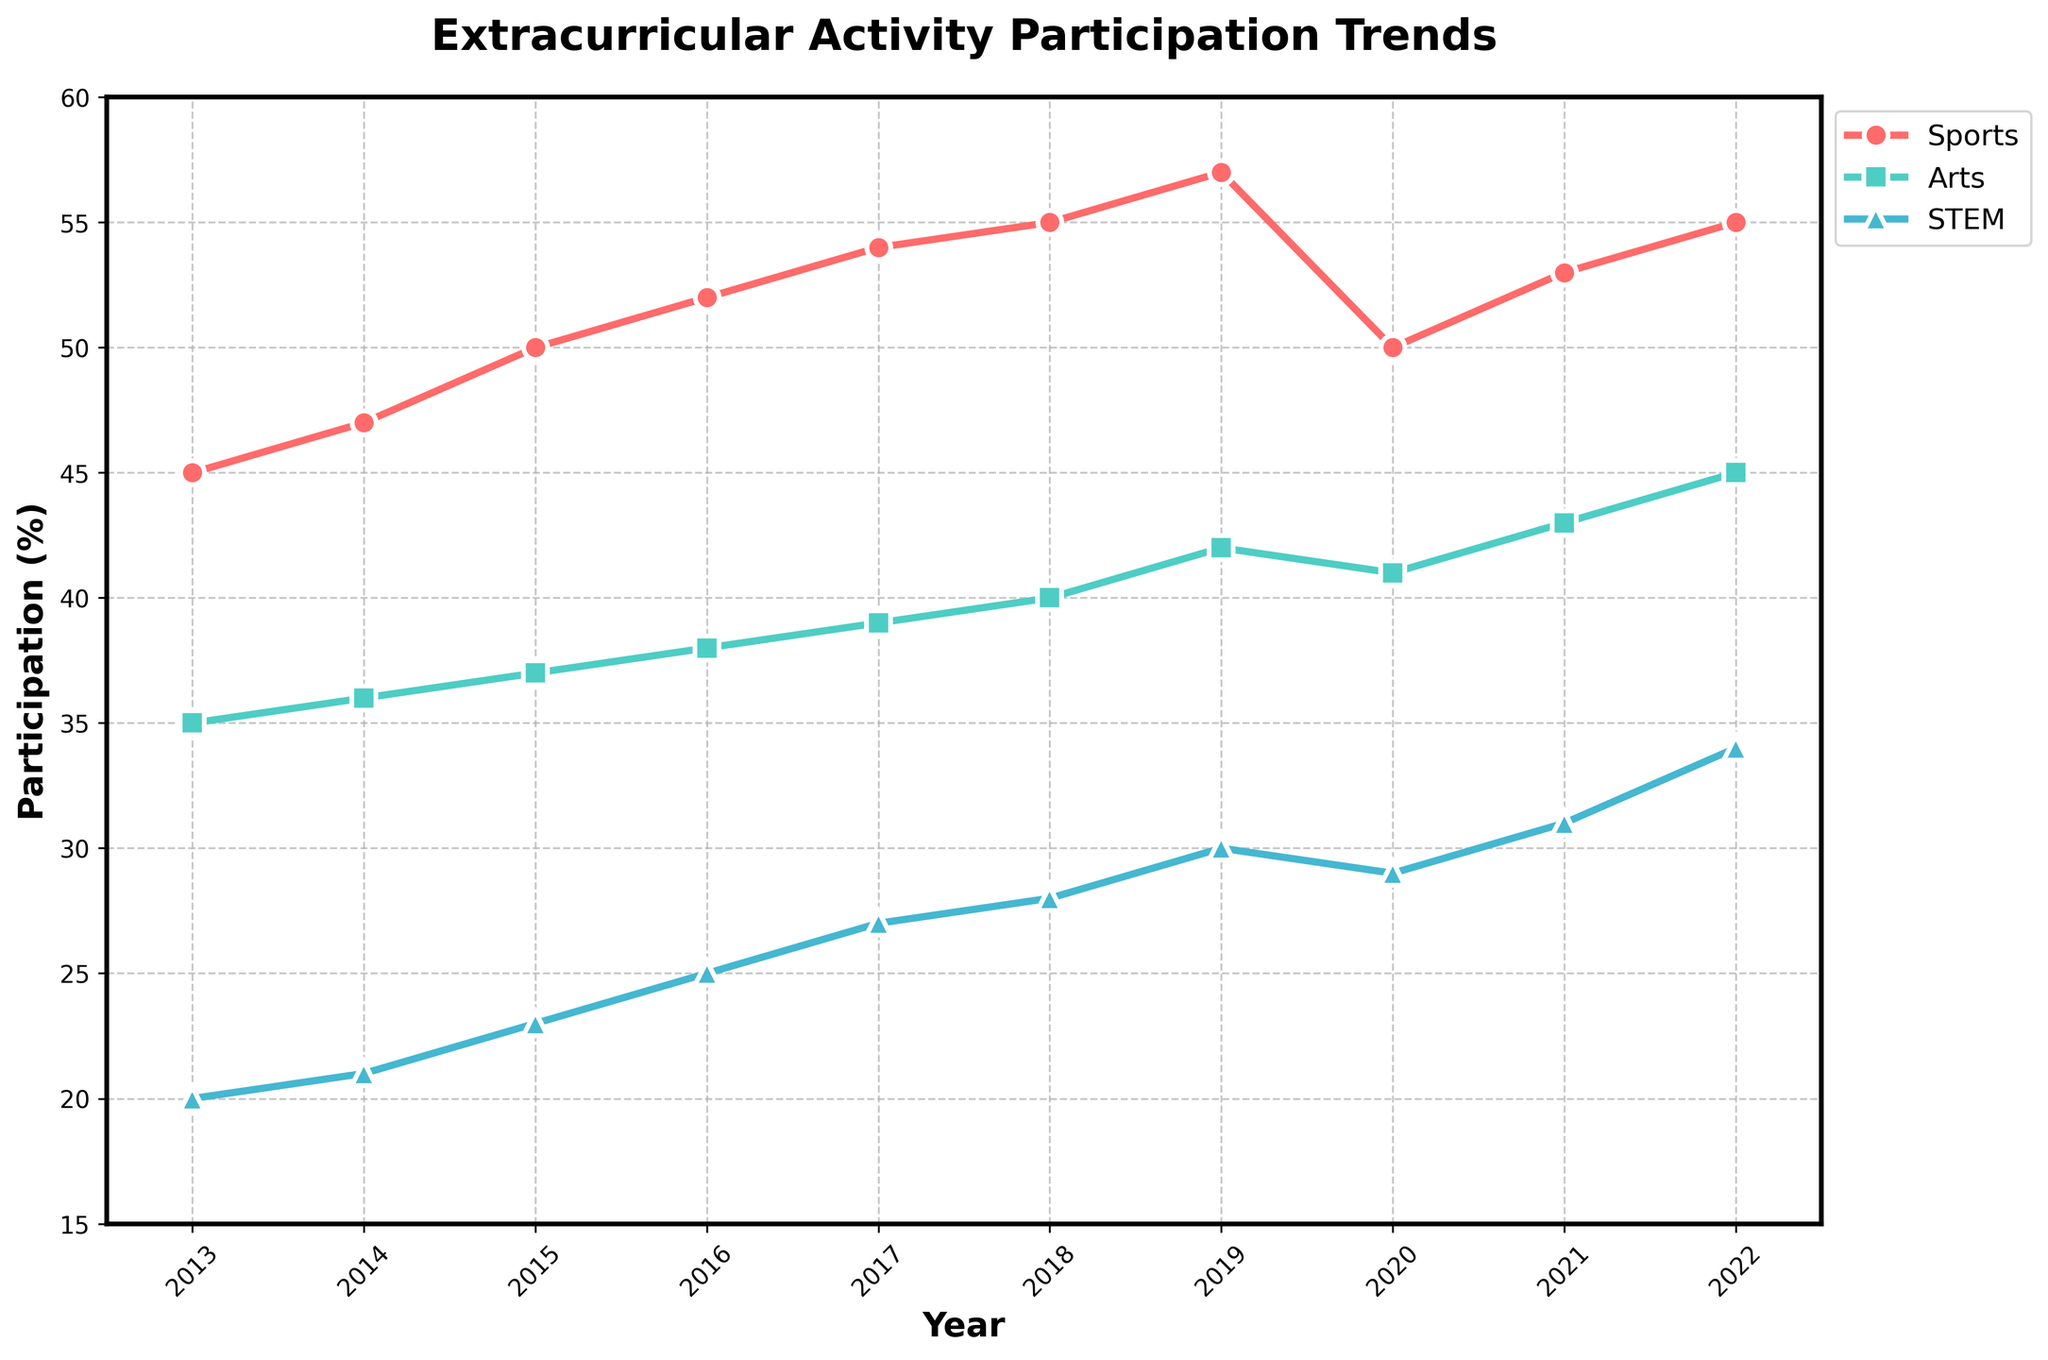What's the title of the figure? The title of the figure is prominently displayed at the top-center part of the chart. To find it, look at the top area above the graph plot.
Answer: Extracurricular Activity Participation Trends What is the percentage of students participating in Arts in 2015? To find this information, look on the y-axis scale and track the data point corresponding to the year 2015 for the Arts line (represented in a distinct color and marker).
Answer: 37% Which activity had the highest participation in 2020? To answer this, examine the data points for each activity in the year 2020. Compare the heights of the markers to determine which is the highest.
Answer: Sports By how much did participation in STEM increase from 2013 to 2022? To determine the increase, subtract the 2013 participation percentage of STEM from the 2022 participation percentage of STEM (34% - 20%).
Answer: 14% What trend can be observed in Sports participation between 2017 and 2022? Look at the Sports line on the graph. Observe how the markers change from 2017 to 2022. Track if it's increasing, decreasing, or fluctuating.
Answer: Increasing In which year did the Arts participation see the smallest increase compared to the previous year? To find the smallest increase, calculate the difference between consecutive years for Arts participation and identify the smallest value.
Answer: 2019 (difference of 1%) Compare the participation in STEM and Arts in 2021. Which one is greater and by how much? Look at the data points for both STEM and Arts in the year 2021. Subtract the percentage of STEM from Arts (43% - 31%).
Answer: Arts by 12% What's the average participation in Sports over the decade? Calculate the average by summing up the annual participation percentages for Sports and dividing by the number of years (10). ((45 + 47 + 50 + 52 + 54 + 55 + 57 + 50 + 53 + 55) / 10).
Answer: 51% Which activity showed the most consistent increase in participation over the decade? Check the lines representing each activity and observe which one has the most linear, consistent upward trend.
Answer: Arts Identify the year when Sports participation declined compared to the previous year. Track the line representing Sports and identify any year where the marker is lower than the previous year's marker.
Answer: 2020 